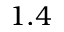Convert formula to latex. <formula><loc_0><loc_0><loc_500><loc_500>1 . 4</formula> 